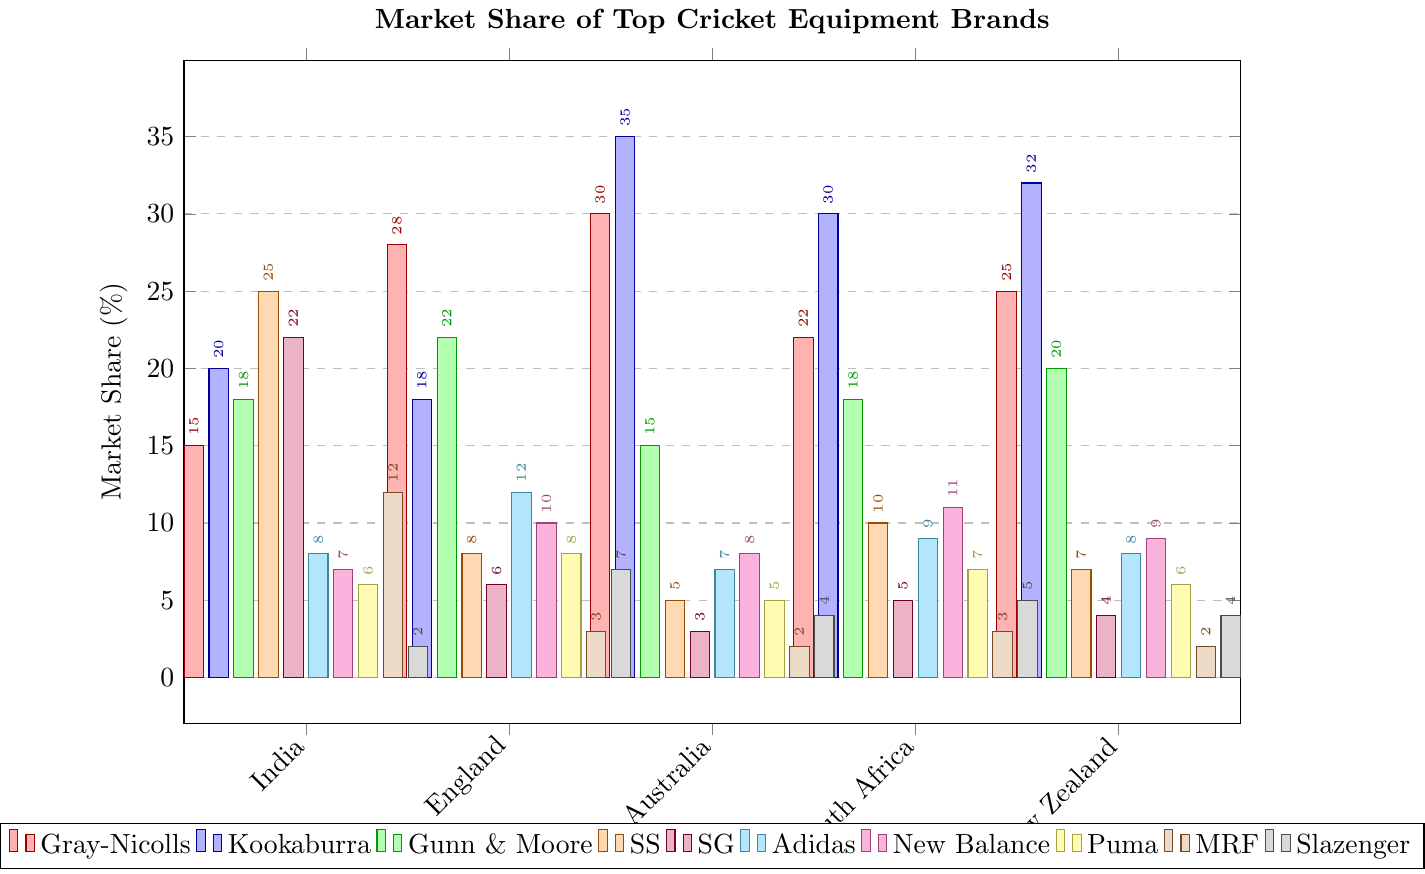Which brand has the highest market share in Australia? Check the bar heights for Australia. The Kookaburra bar is the tallest.
Answer: Kookaburra Compare the market shares of Gray-Nicolls and Kookaburra in England. Which one is higher? Look at the bars corresponding to Gray-Nicolls and Kookaburra for England. Gray-Nicolls has a higher bar than Kookaburra.
Answer: Gray-Nicolls Sum the market shares of SG across all countries. Add the values for SG in all countries: 22 (India) + 6 (England) + 3 (Australia) + 5 (South Africa) + 4 (New Zealand) = 40.
Answer: 40 What's the average market share of New Balance in all countries? Add the values for New Balance in all countries then divide by the number of countries. (7 + 10 + 8 + 11 + 9) / 5 = 45 / 5 = 9.
Answer: 9 Which brand has the lowest market share in South Africa? Find the shortest bar in South Africa. MRF has the smallest bar.
Answer: MRF Compare the total market share of SS and Gunn & Moore in New Zealand. Which one is higher? Check the bars for SS and Gunn & Moore in New Zealand. SS has 7 and Gunn & Moore has 20. Gunn & Moore has a higher total market share.
Answer: Gunn & Moore Which country does Gray-Nicolls have the lowest market share in? Look for the shortest Gray-Nicolls bar across all countries. It's India at 15.
Answer: India What's the difference in market share between Adidas and Puma in all countries? Find the individual differences and sum them: (India: 8 - 6) + (England: 12 - 8) + (Australia: 7 - 5) + (South Africa: 9 - 7) + (New Zealand: 8 - 6) = 2 + 4 + 2 + 2 + 2 = 12.
Answer: 12 Is the market share of SG in England greater than or less than the market share of MRF in South Africa? Compare the bars: SG (England) has 6 and MRF (South Africa) has 3. 6 > 3, so it is greater.
Answer: Greater 